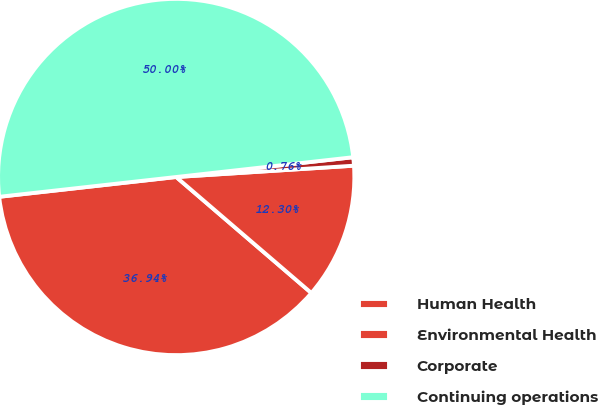<chart> <loc_0><loc_0><loc_500><loc_500><pie_chart><fcel>Human Health<fcel>Environmental Health<fcel>Corporate<fcel>Continuing operations<nl><fcel>36.94%<fcel>12.3%<fcel>0.76%<fcel>50.0%<nl></chart> 